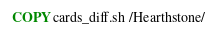<code> <loc_0><loc_0><loc_500><loc_500><_Dockerfile_>COPY cards_diff.sh /Hearthstone/
</code> 